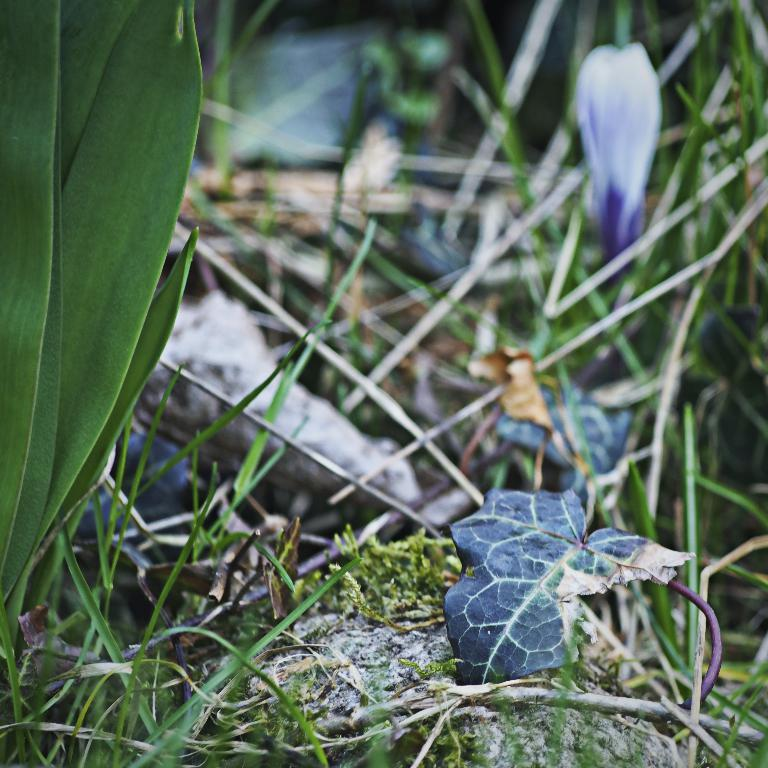What is the main subject of the image? The main subject of the image is a group of leaves of plants. Can you describe the leaves in the image? Unfortunately, the provided facts do not include any details about the leaves, so we cannot describe them further. What type of scarf is being used to clean the leaves in the image? There is no scarf present in the image, and the leaves are not being cleaned. 